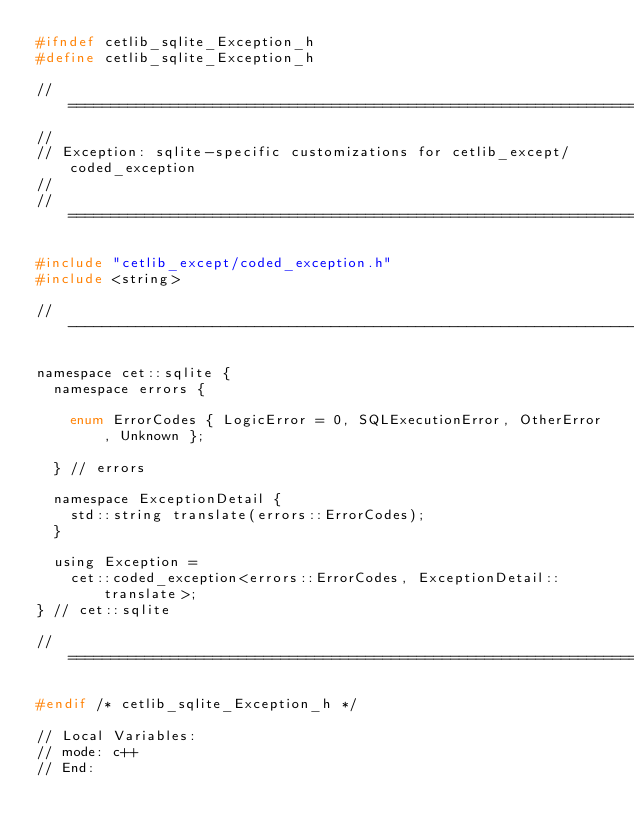Convert code to text. <code><loc_0><loc_0><loc_500><loc_500><_C_>#ifndef cetlib_sqlite_Exception_h
#define cetlib_sqlite_Exception_h

// ======================================================================
//
// Exception: sqlite-specific customizations for cetlib_except/coded_exception
//
// ======================================================================

#include "cetlib_except/coded_exception.h"
#include <string>

// ----------------------------------------------------------------------

namespace cet::sqlite {
  namespace errors {

    enum ErrorCodes { LogicError = 0, SQLExecutionError, OtherError, Unknown };

  } // errors

  namespace ExceptionDetail {
    std::string translate(errors::ErrorCodes);
  }

  using Exception =
    cet::coded_exception<errors::ErrorCodes, ExceptionDetail::translate>;
} // cet::sqlite

// ======================================================================

#endif /* cetlib_sqlite_Exception_h */

// Local Variables:
// mode: c++
// End:
</code> 